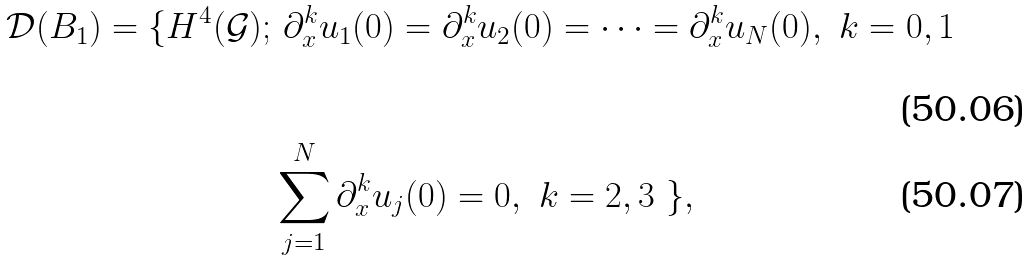<formula> <loc_0><loc_0><loc_500><loc_500>\mathcal { D } ( B _ { 1 } ) = \{ H ^ { 4 } ( \mathcal { G } ) ; & \ \partial _ { x } ^ { k } u _ { 1 } ( 0 ) = \partial _ { x } ^ { k } u _ { 2 } ( 0 ) = \cdots = \partial _ { x } ^ { k } u _ { N } ( 0 ) , \ k = 0 , 1 \\ & \sum _ { j = 1 } ^ { N } \partial _ { x } ^ { k } u _ { j } ( 0 ) = 0 , \ k = 2 , 3 \ \} ,</formula> 